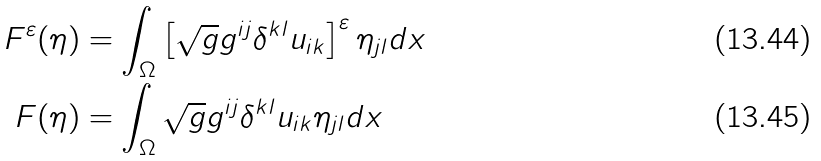<formula> <loc_0><loc_0><loc_500><loc_500>F ^ { \varepsilon } ( \eta ) & = \int _ { \Omega } \left [ \sqrt { g } g ^ { i j } \delta ^ { k l } u _ { i k } \right ] ^ { \varepsilon } \eta _ { j l } d x \\ F ( \eta ) & = \int _ { \Omega } \sqrt { g } g ^ { i j } \delta ^ { k l } u _ { i k } \eta _ { j l } d x</formula> 